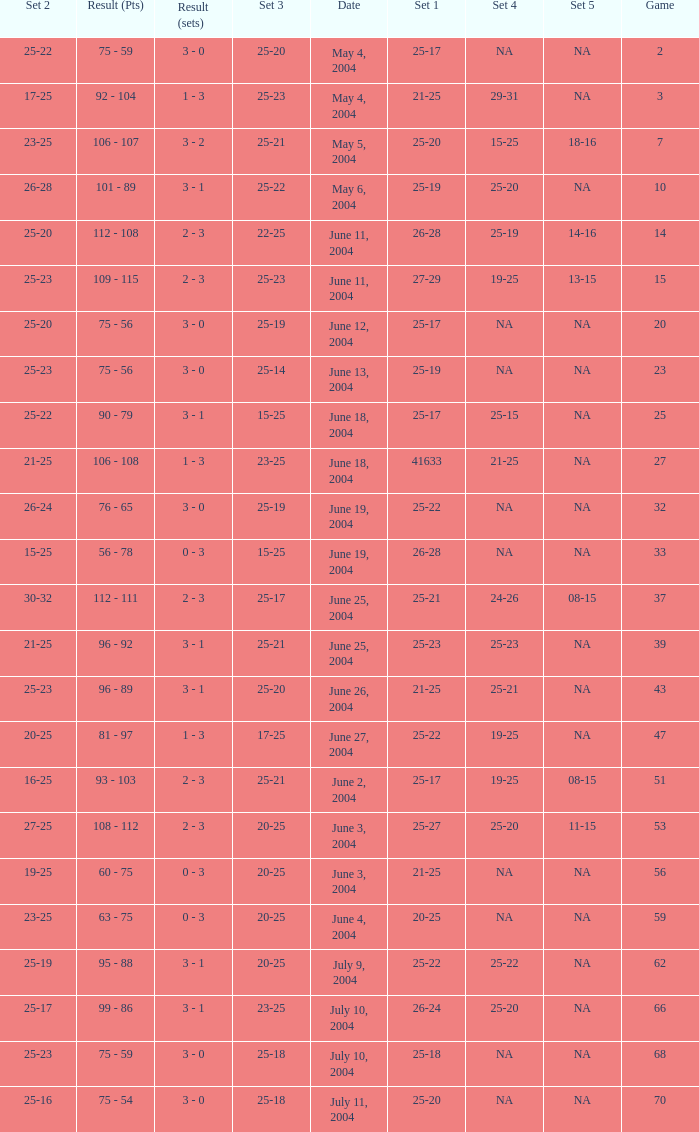What is the set 5 for the game with a set 2 of 21-25 and a set 1 of 41633? NA. 